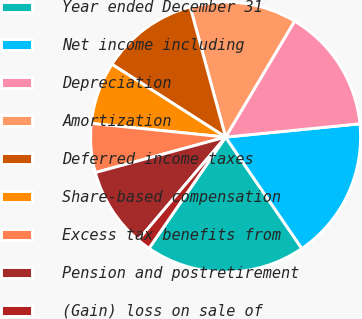Convert chart. <chart><loc_0><loc_0><loc_500><loc_500><pie_chart><fcel>Year ended December 31<fcel>Net income including<fcel>Depreciation<fcel>Amortization<fcel>Deferred income taxes<fcel>Share-based compensation<fcel>Excess tax benefits from<fcel>Pension and postretirement<fcel>(Gain) loss on sale of<nl><fcel>19.15%<fcel>17.02%<fcel>14.89%<fcel>12.77%<fcel>11.7%<fcel>7.45%<fcel>5.85%<fcel>9.57%<fcel>1.6%<nl></chart> 